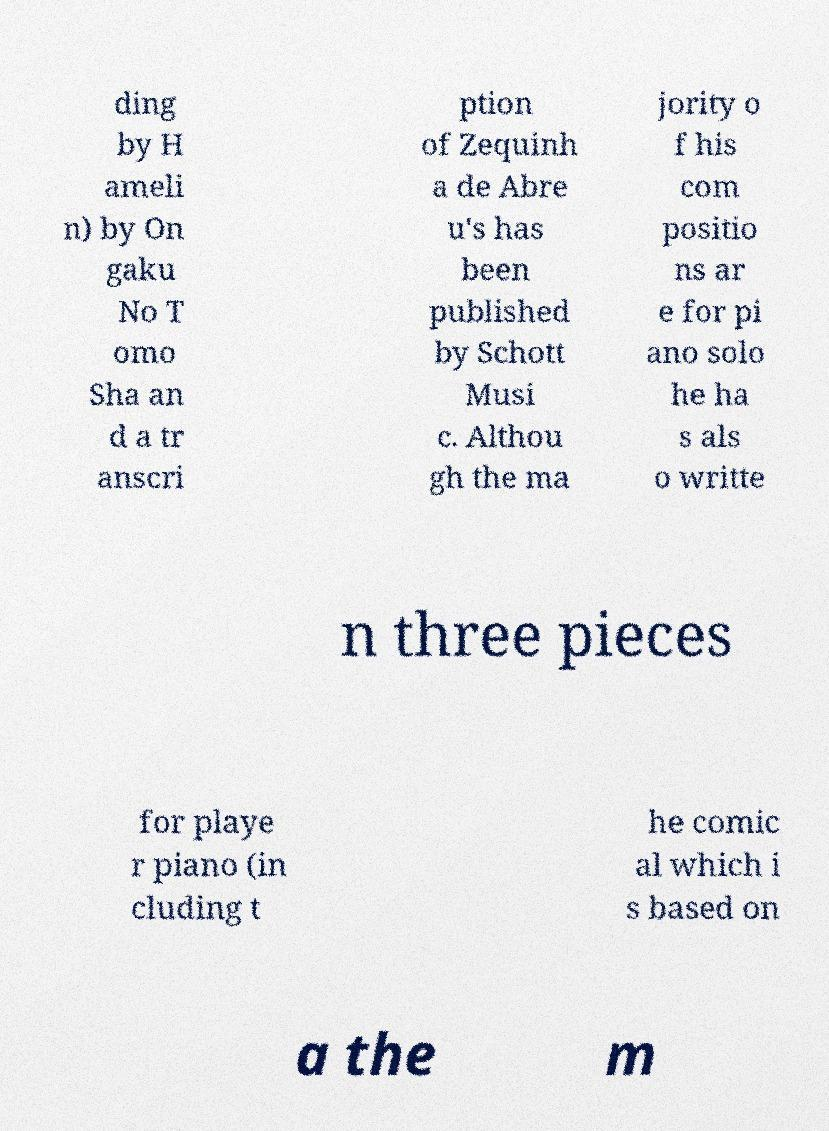Please identify and transcribe the text found in this image. ding by H ameli n) by On gaku No T omo Sha an d a tr anscri ption of Zequinh a de Abre u's has been published by Schott Musi c. Althou gh the ma jority o f his com positio ns ar e for pi ano solo he ha s als o writte n three pieces for playe r piano (in cluding t he comic al which i s based on a the m 